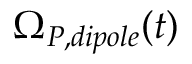Convert formula to latex. <formula><loc_0><loc_0><loc_500><loc_500>\Omega _ { P , d i p o l e } ( t )</formula> 